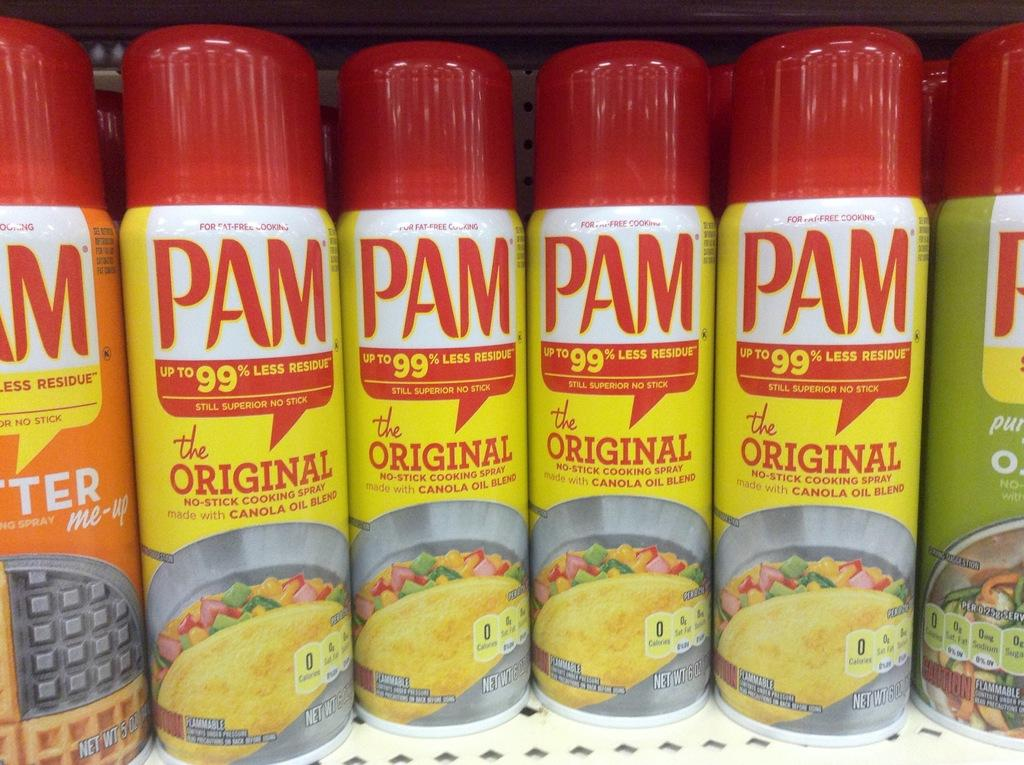What objects are present in the image? There are bottles in the image. What can be seen on the bottles? The bottles have text on them. Where are the bottles located? The bottles are placed on a surface. How does the tongue interact with the bottles in the image? There is no tongue present in the image, so it cannot interact with the bottles. 